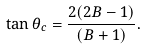Convert formula to latex. <formula><loc_0><loc_0><loc_500><loc_500>\tan \theta _ { c } = \frac { 2 ( 2 B - 1 ) } { ( B + 1 ) } .</formula> 